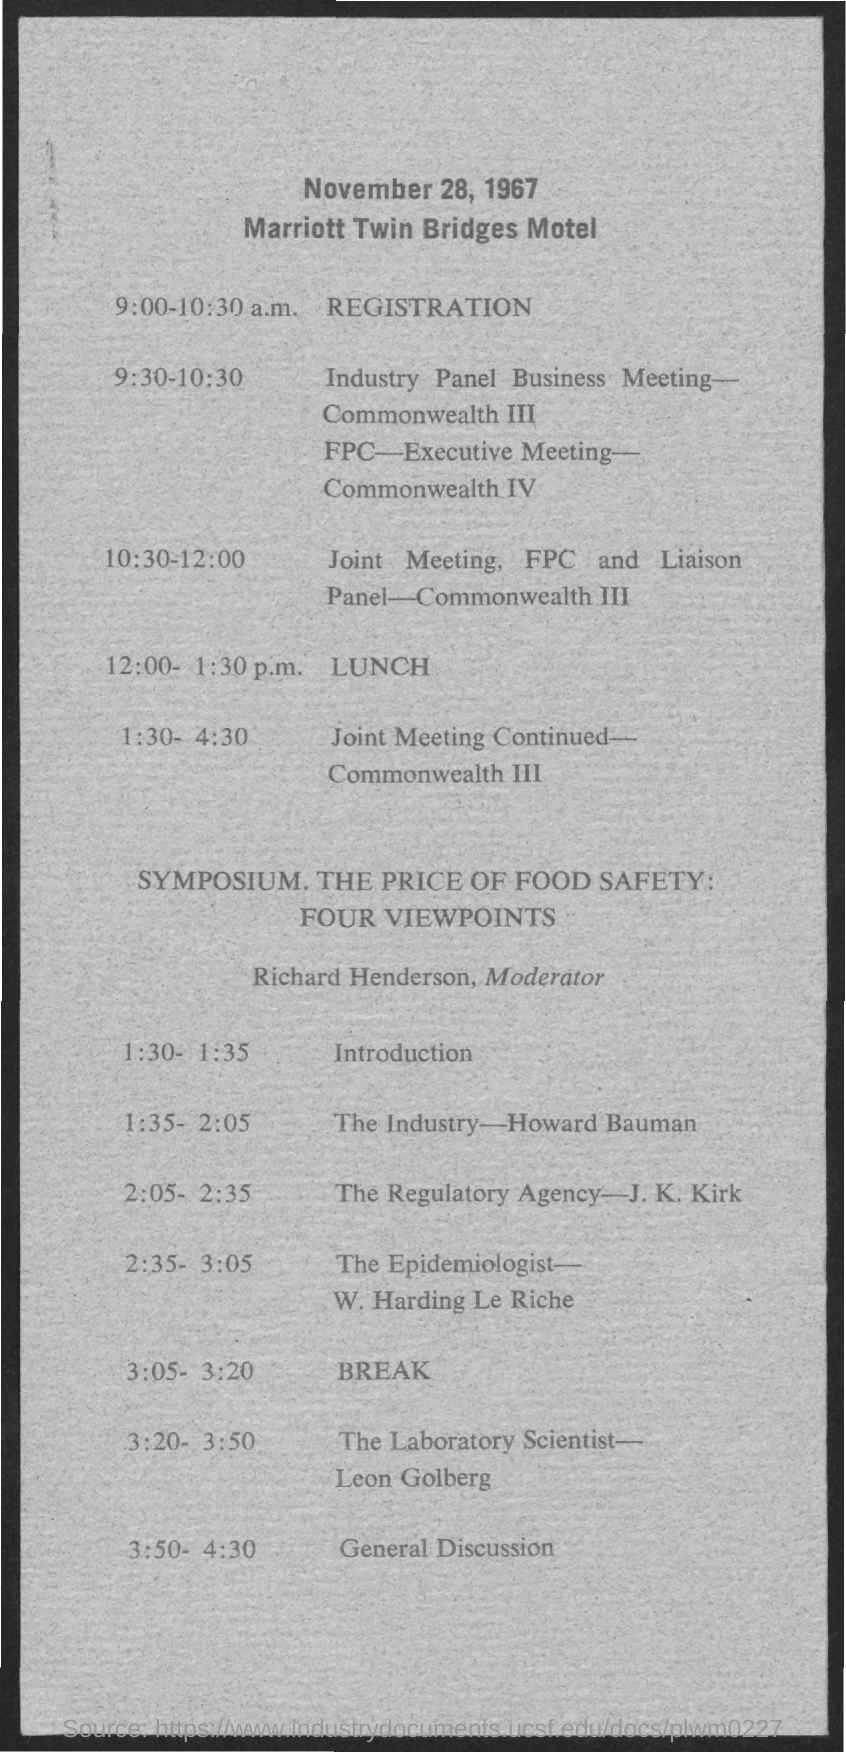What is the name of Motel
Your answer should be very brief. General Discussion. 